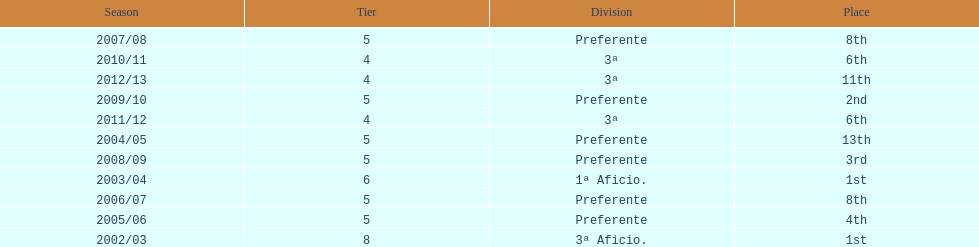In what year did the team achieve the same place as 2010/11? 2011/12. 